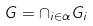Convert formula to latex. <formula><loc_0><loc_0><loc_500><loc_500>G = \cap _ { i \in \alpha } G _ { i }</formula> 